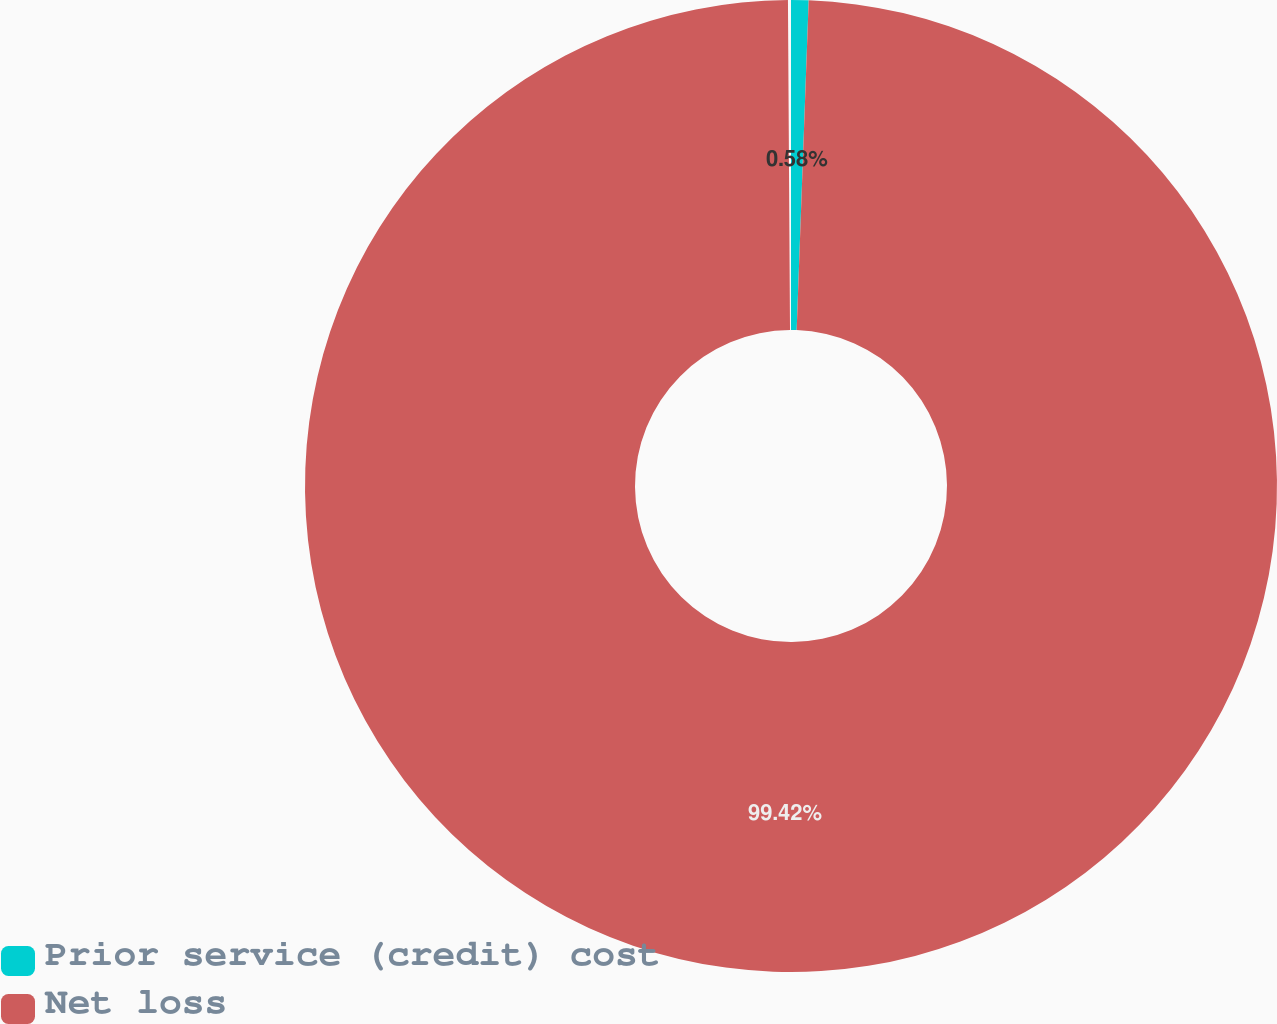Convert chart to OTSL. <chart><loc_0><loc_0><loc_500><loc_500><pie_chart><fcel>Prior service (credit) cost<fcel>Net loss<nl><fcel>0.58%<fcel>99.42%<nl></chart> 